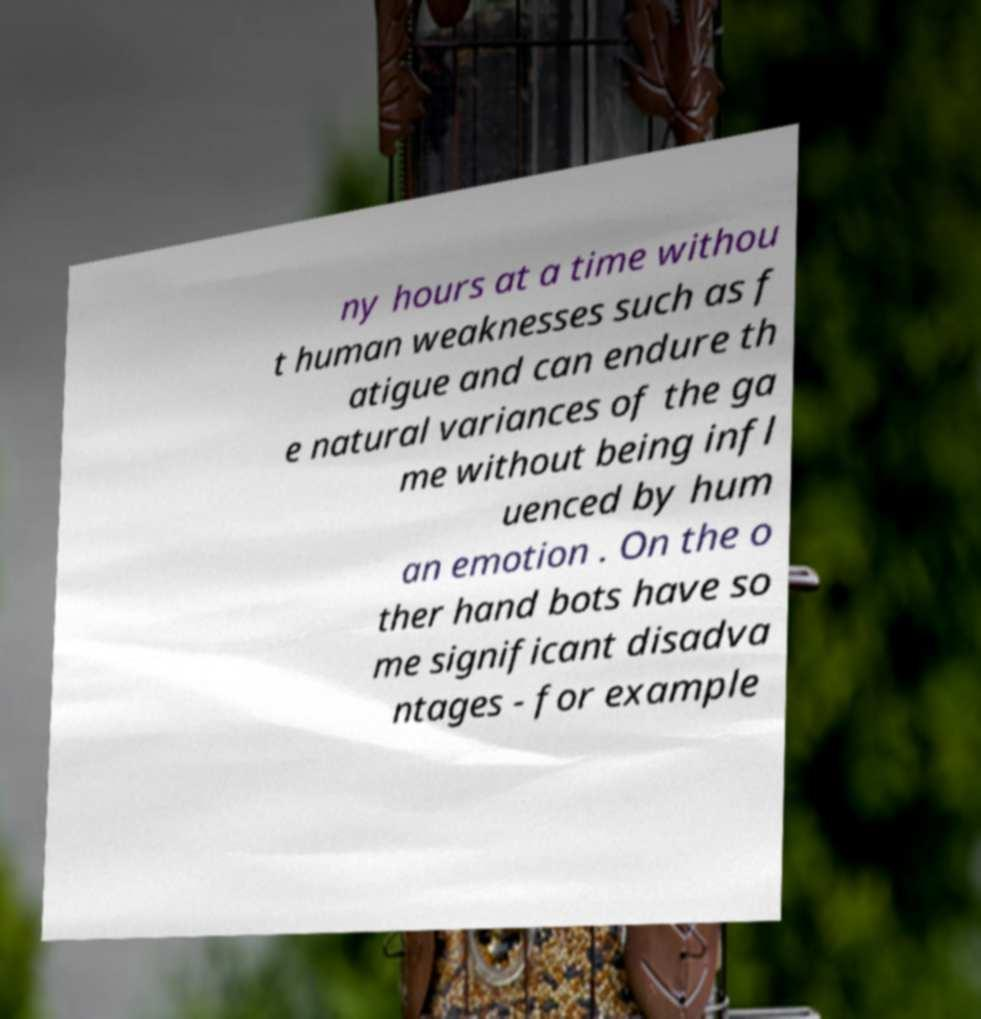Can you read and provide the text displayed in the image?This photo seems to have some interesting text. Can you extract and type it out for me? ny hours at a time withou t human weaknesses such as f atigue and can endure th e natural variances of the ga me without being infl uenced by hum an emotion . On the o ther hand bots have so me significant disadva ntages - for example 